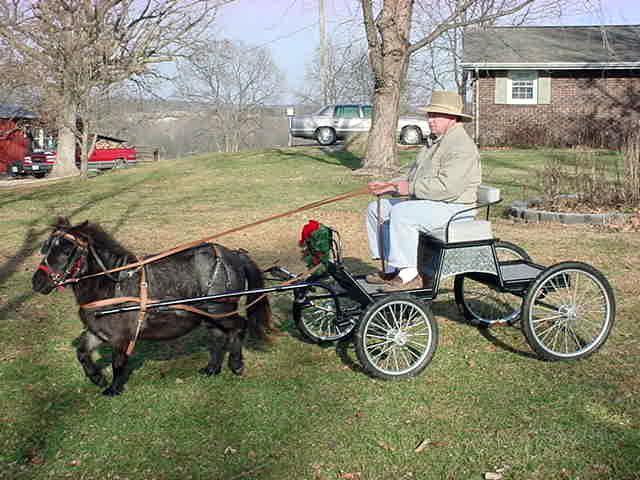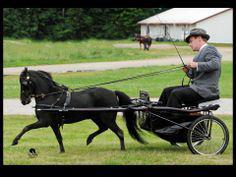The first image is the image on the left, the second image is the image on the right. For the images displayed, is the sentence "In at least one image there is a single man with a hat on a cart being pulled by at least one mini horse." factually correct? Answer yes or no. Yes. The first image is the image on the left, the second image is the image on the right. For the images shown, is this caption "A man in a hat is riding on the seat of a leftward-facing four-wheeled wagon pulled by one small black pony." true? Answer yes or no. Yes. 